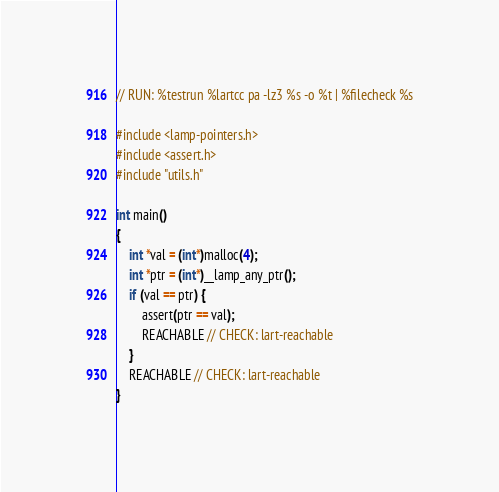Convert code to text. <code><loc_0><loc_0><loc_500><loc_500><_C_>// RUN: %testrun %lartcc pa -lz3 %s -o %t | %filecheck %s

#include <lamp-pointers.h>
#include <assert.h>
#include "utils.h"

int main()
{
    int *val = (int*)malloc(4);
    int *ptr = (int*)__lamp_any_ptr();
    if (val == ptr) {
        assert(ptr == val);
        REACHABLE // CHECK: lart-reachable
    }
    REACHABLE // CHECK: lart-reachable
}</code> 